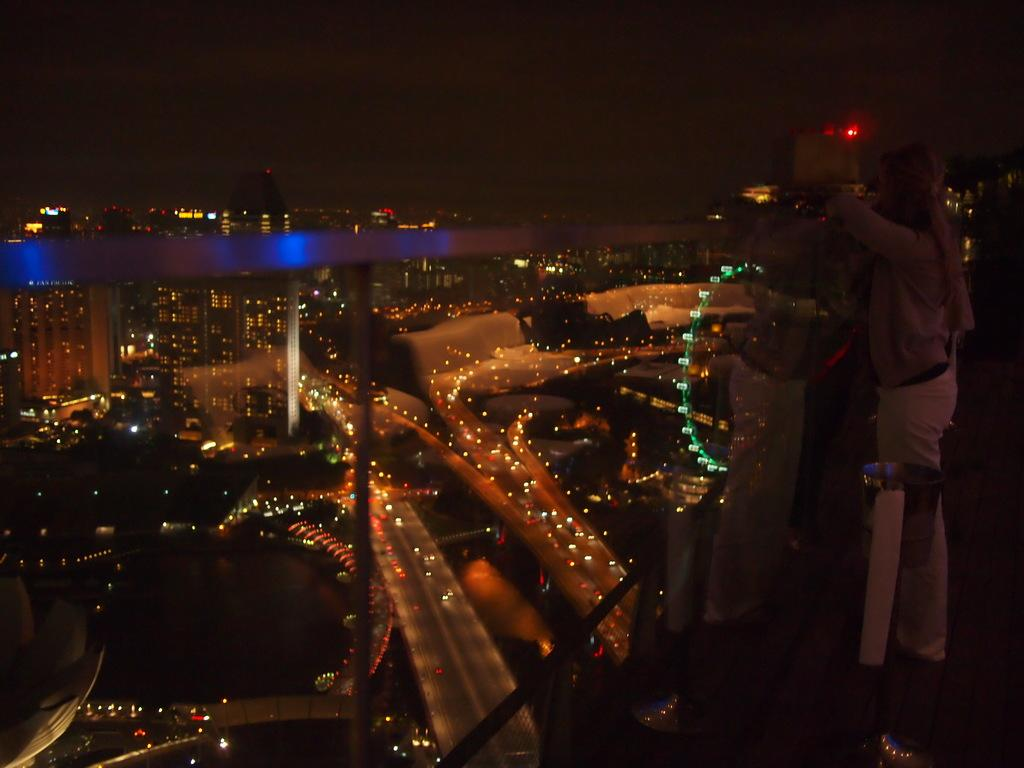Where was the image taken? The image was taken outside. What can be seen in the middle of the image? There are vehicles and many lights in the middle of the image. Is there anyone visible in the image? Yes, there is a person standing on the right side of the image. What type of engine is visible in the image? There is no engine visible in the image. Is there a sidewalk in the image? The provided facts do not mention a sidewalk, so it cannot be determined from the image. 